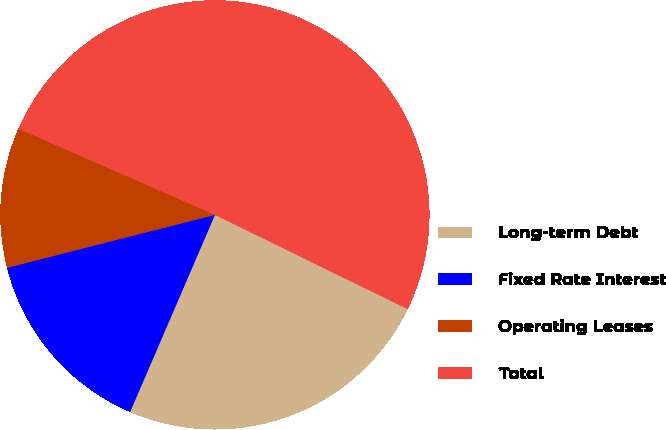Convert chart to OTSL. <chart><loc_0><loc_0><loc_500><loc_500><pie_chart><fcel>Long-term Debt<fcel>Fixed Rate Interest<fcel>Operating Leases<fcel>Total<nl><fcel>24.23%<fcel>14.56%<fcel>10.55%<fcel>50.66%<nl></chart> 